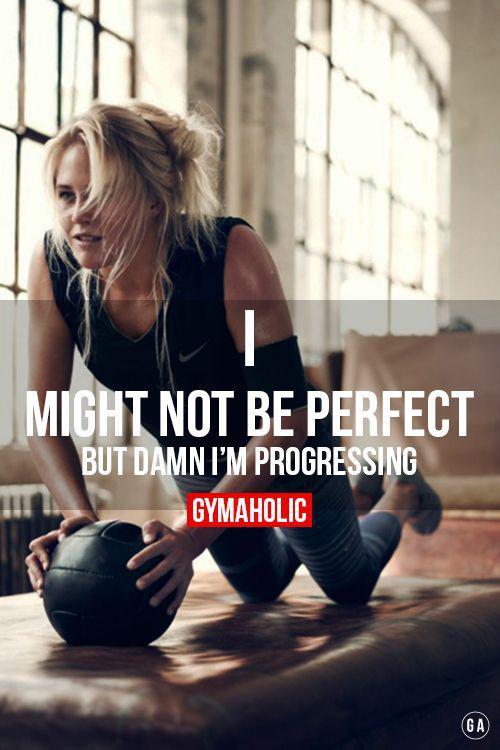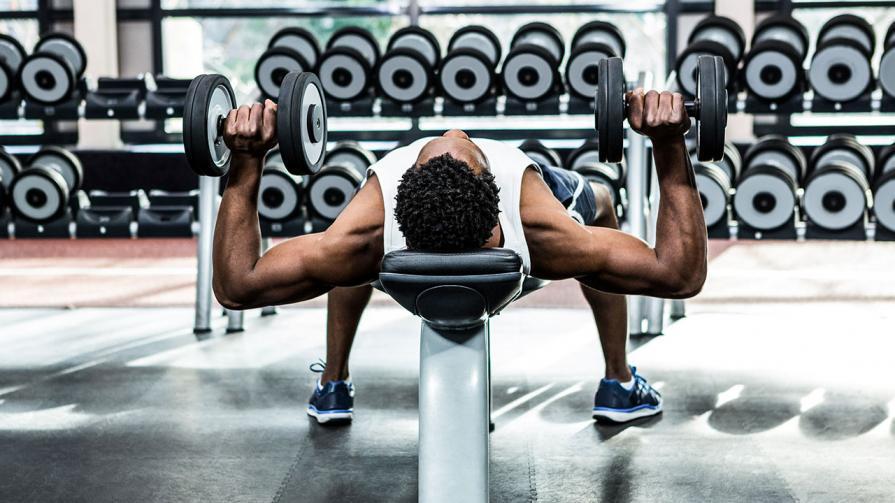The first image is the image on the left, the second image is the image on the right. For the images shown, is this caption "An image shows a man grasping weights and facing the floor, with body extended horizontally plank-style." true? Answer yes or no. No. The first image is the image on the left, the second image is the image on the right. Assess this claim about the two images: "In one image a bodybuilder, facing the floor, is balanced on the toes of his feet and has at least one hand on the floor gripping a small barbell.". Correct or not? Answer yes or no. No. 